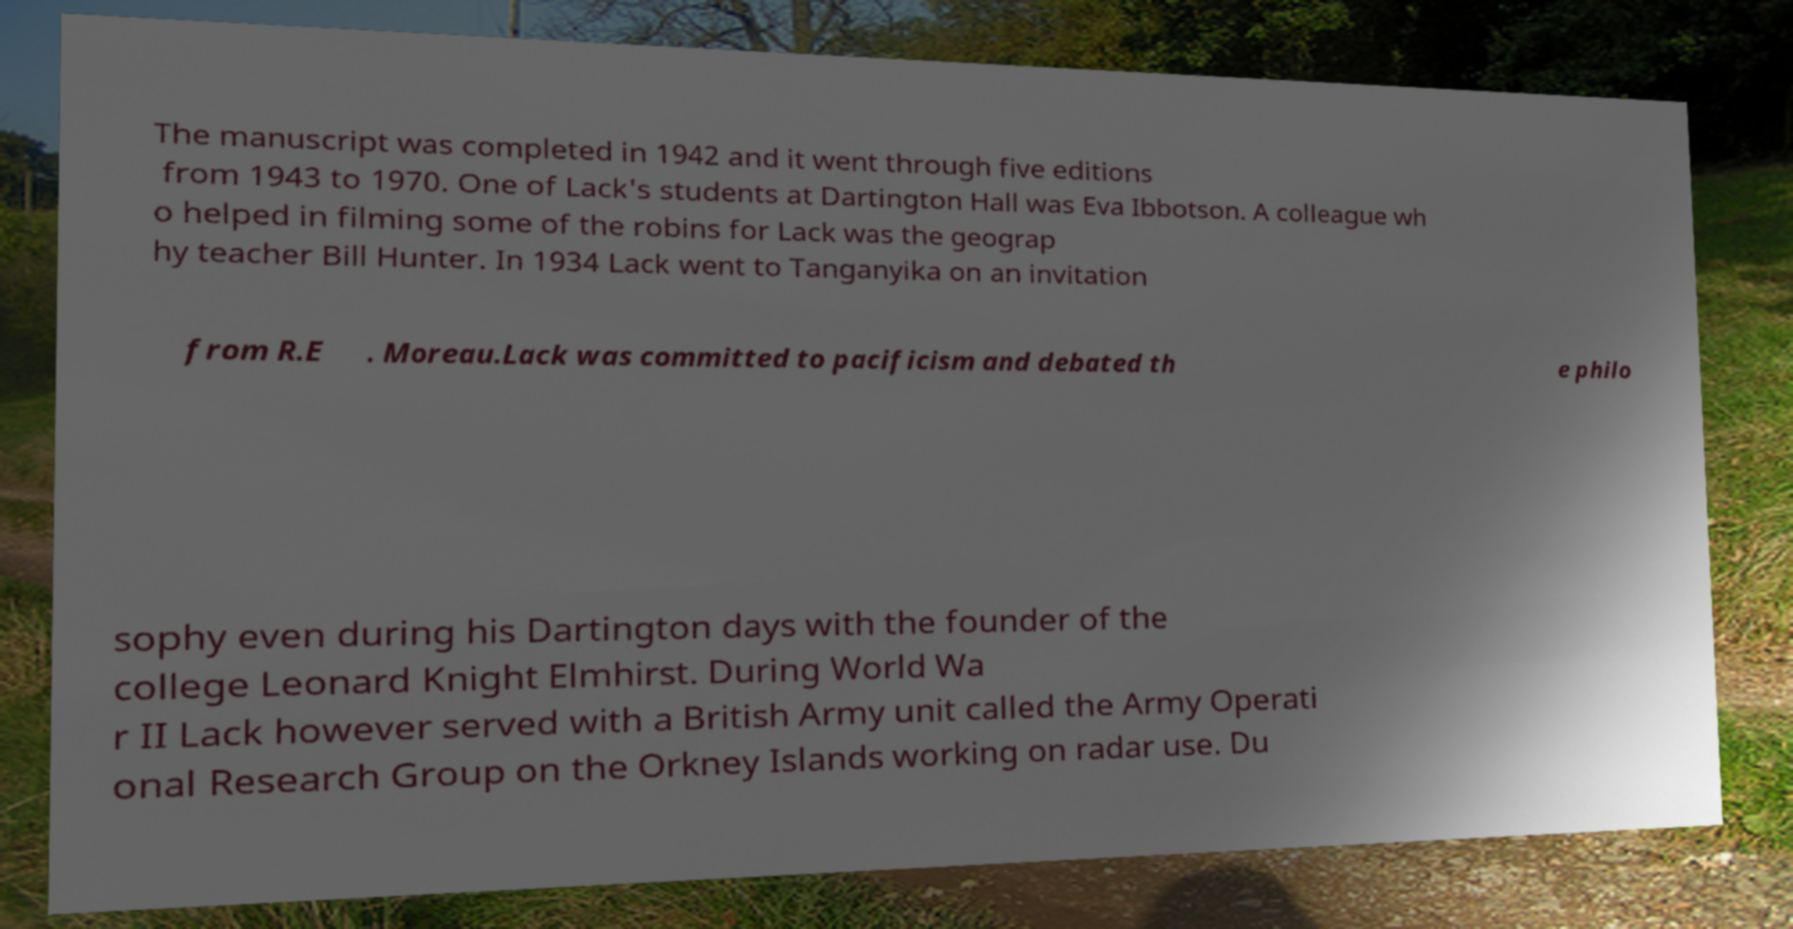I need the written content from this picture converted into text. Can you do that? The manuscript was completed in 1942 and it went through five editions from 1943 to 1970. One of Lack's students at Dartington Hall was Eva Ibbotson. A colleague wh o helped in filming some of the robins for Lack was the geograp hy teacher Bill Hunter. In 1934 Lack went to Tanganyika on an invitation from R.E . Moreau.Lack was committed to pacificism and debated th e philo sophy even during his Dartington days with the founder of the college Leonard Knight Elmhirst. During World Wa r II Lack however served with a British Army unit called the Army Operati onal Research Group on the Orkney Islands working on radar use. Du 